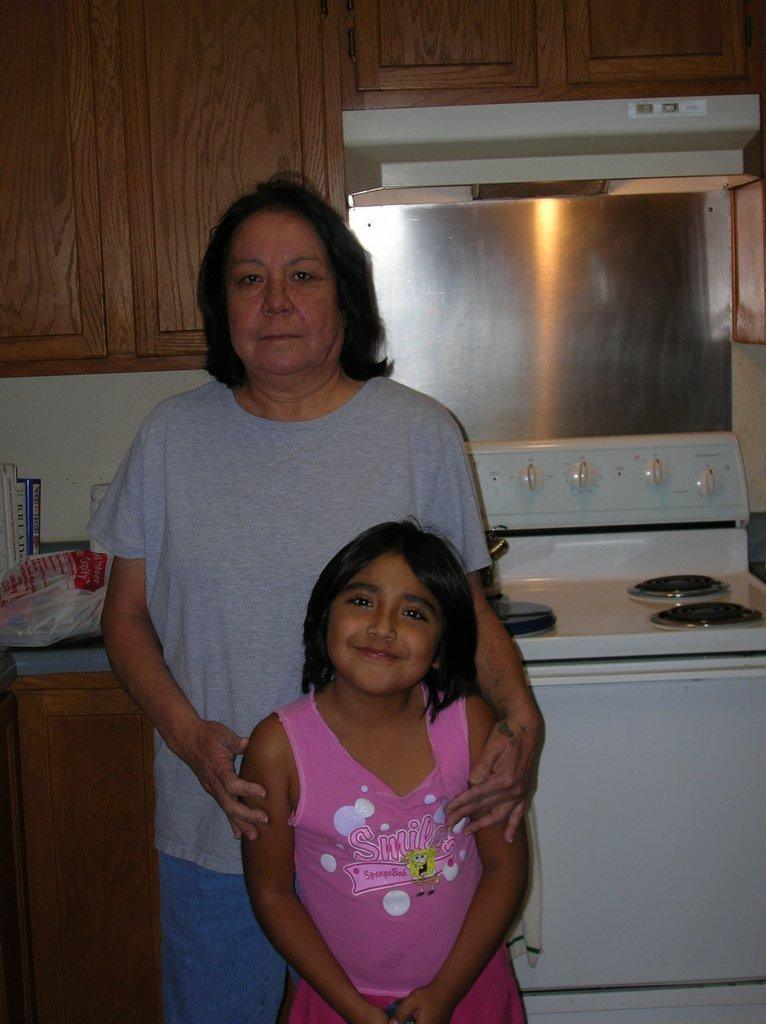How many people are in the image? There are two persons in the image. Can you describe the two people? One of the persons is a woman, and the other person is a girl. What is located behind the two persons? There is a stove behind the two persons. What type of furniture is visible in the image? There are cupboards at the top in the image. What type of tools does the carpenter use in the image? There is no carpenter present in the image. Can you tell me how many books are on the table in the image? There is no table or books visible in the image. 